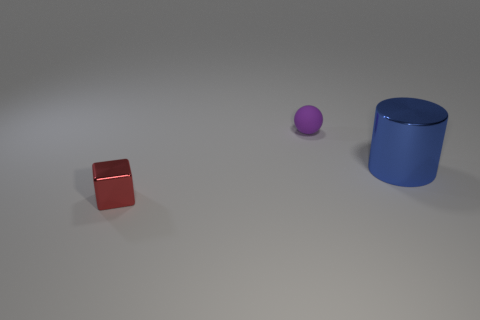There is a tiny red thing that is made of the same material as the big cylinder; what shape is it?
Your answer should be compact. Cube. Is the shape of the object that is in front of the metal cylinder the same as  the purple thing?
Your answer should be very brief. No. The shiny thing left of the large blue cylinder has what shape?
Your answer should be very brief. Cube. What number of red metallic things are the same size as the blue object?
Make the answer very short. 0. The metallic cube is what color?
Offer a very short reply. Red. Do the metallic cube and the shiny thing that is behind the tiny red shiny object have the same color?
Provide a succinct answer. No. There is a cube that is made of the same material as the large blue object; what size is it?
Provide a short and direct response. Small. Is there a small matte cylinder that has the same color as the metal block?
Provide a short and direct response. No. What number of objects are either small things to the right of the small red object or red metal things?
Provide a short and direct response. 2. Does the blue cylinder have the same material as the purple object that is behind the large blue shiny object?
Make the answer very short. No. 